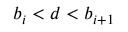Convert formula to latex. <formula><loc_0><loc_0><loc_500><loc_500>b _ { i } < d < b _ { i + 1 }</formula> 